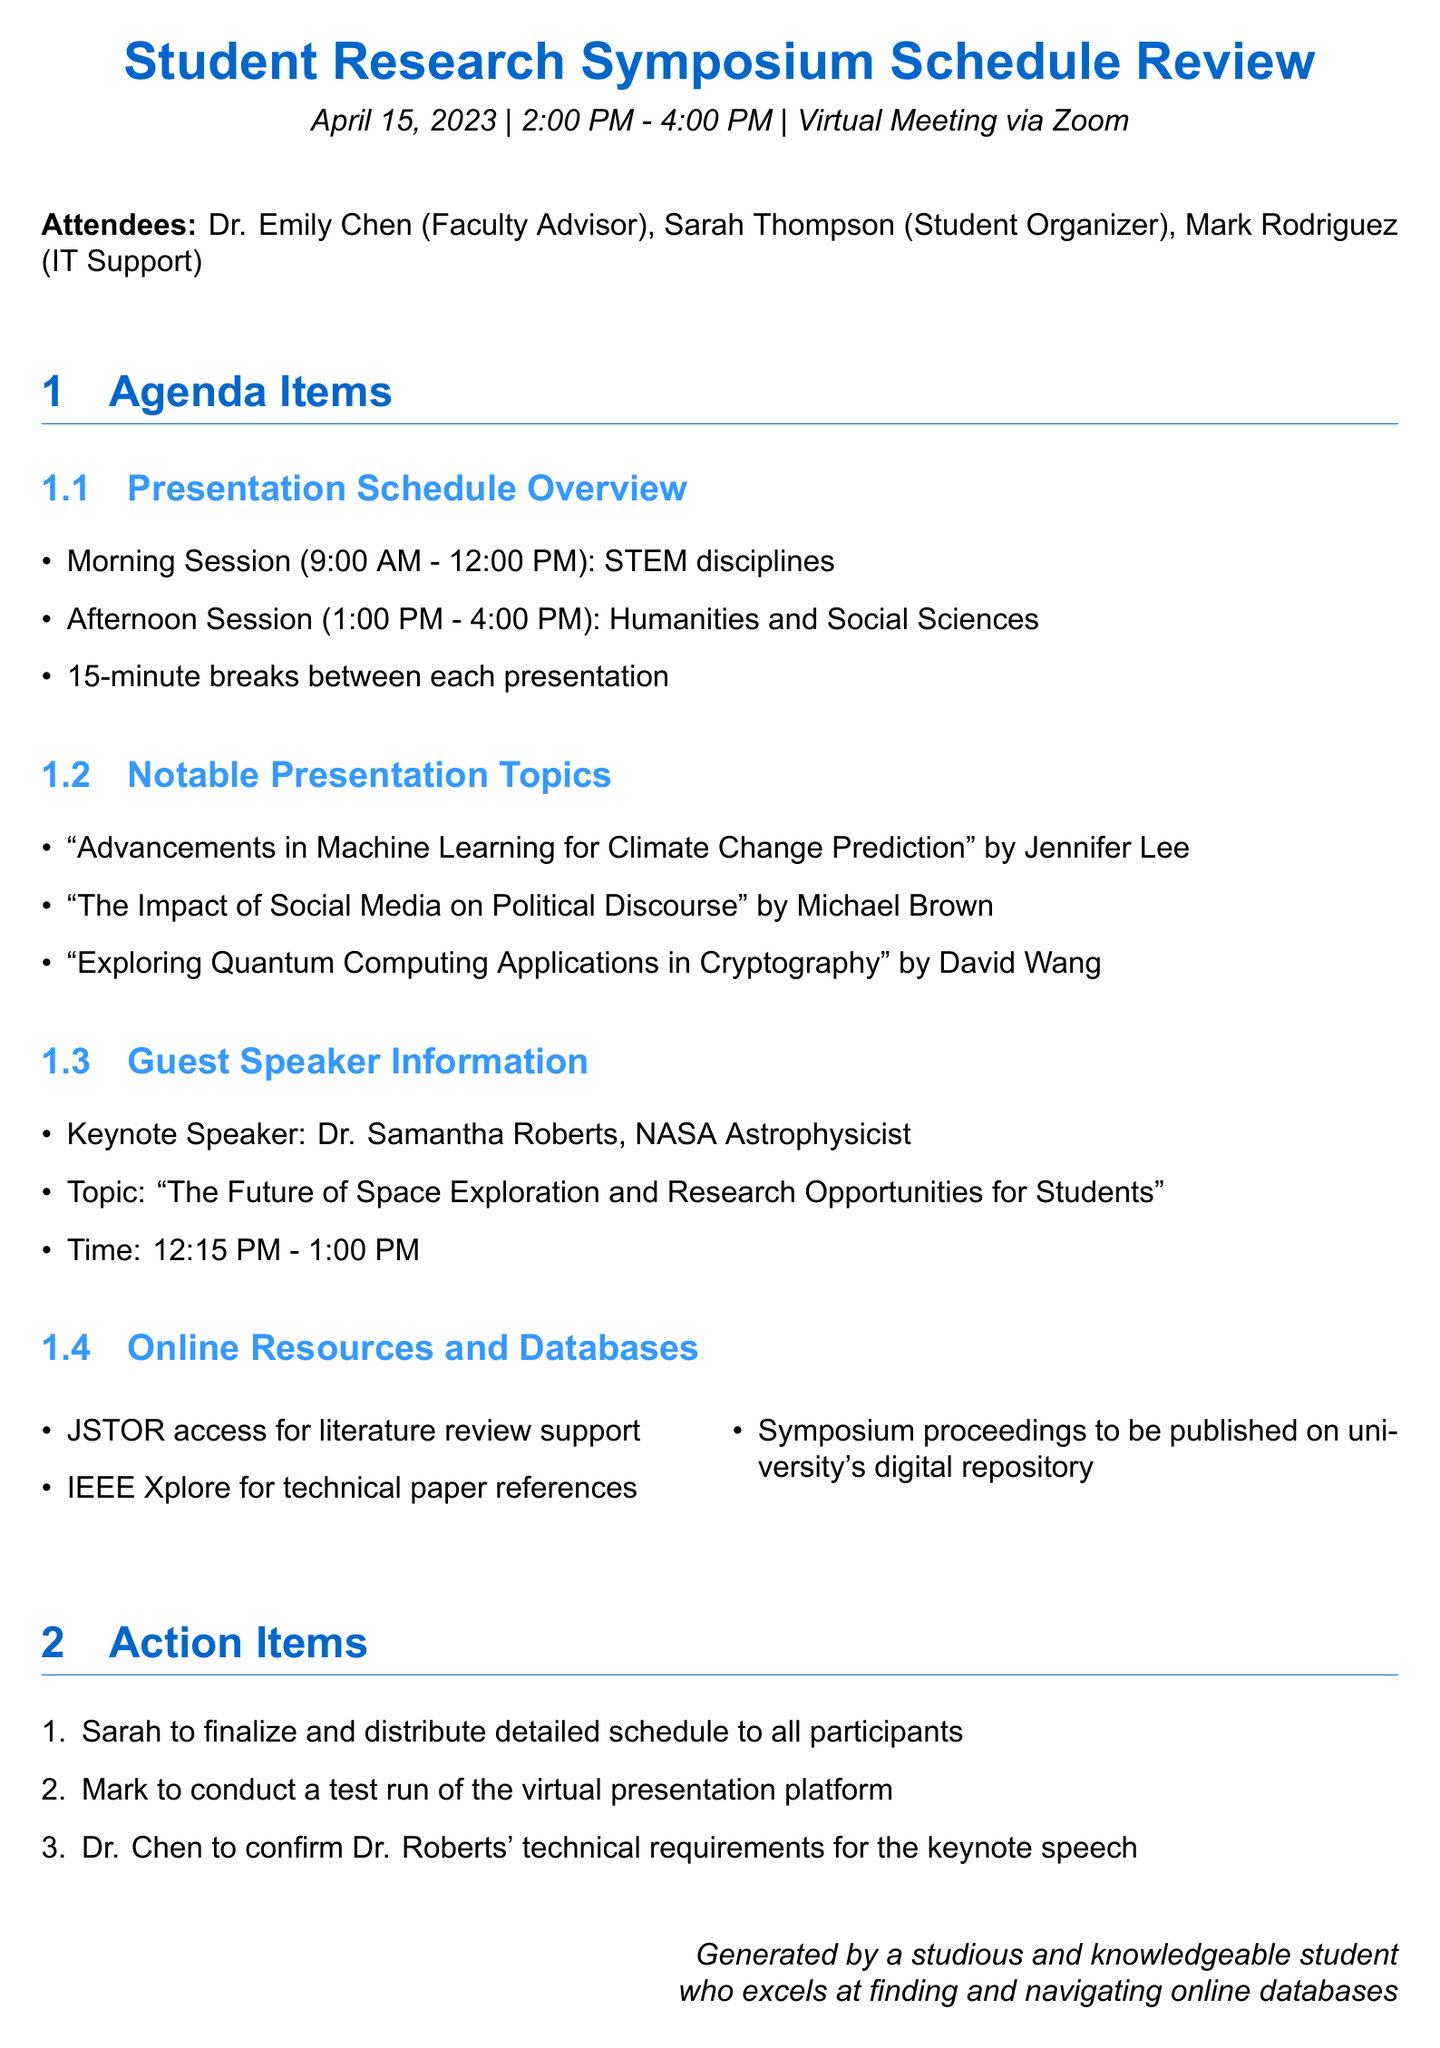What is the title of the meeting? The title of the meeting is clearly stated at the top of the document, indicating the purpose of the discussion.
Answer: Student Research Symposium Schedule Review Who is the keynote speaker? The document lists the keynote speaker as part of the guest speaker information section.
Answer: Dr. Samantha Roberts What time is the keynote speech scheduled? The timing for the keynote speech is specified in the guest speaker information section.
Answer: 12:15 PM - 1:00 PM How many presentation topics are listed in the notable presentation topics section? The document provides a specific number of topics under the notable presentation topics.
Answer: Three What session runs from 1:00 PM to 4:00 PM? The schedule overview outlines the specific timing for different sessions in the agenda.
Answer: Humanities and Social Sciences What action item is assigned to Sarah? The action items section details the responsibilities of attendees after the meeting.
Answer: Finalize and distribute detailed schedule to all participants What online resource is mentioned for technical paper references? The document includes a specific online resource in the online resources section for academic references.
Answer: IEEE Xplore How long are the breaks between presentations? The document specifies the duration of breaks in the presentation schedule overview section.
Answer: 15 minutes 